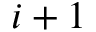<formula> <loc_0><loc_0><loc_500><loc_500>i + 1</formula> 